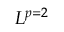Convert formula to latex. <formula><loc_0><loc_0><loc_500><loc_500>L ^ { p = 2 }</formula> 